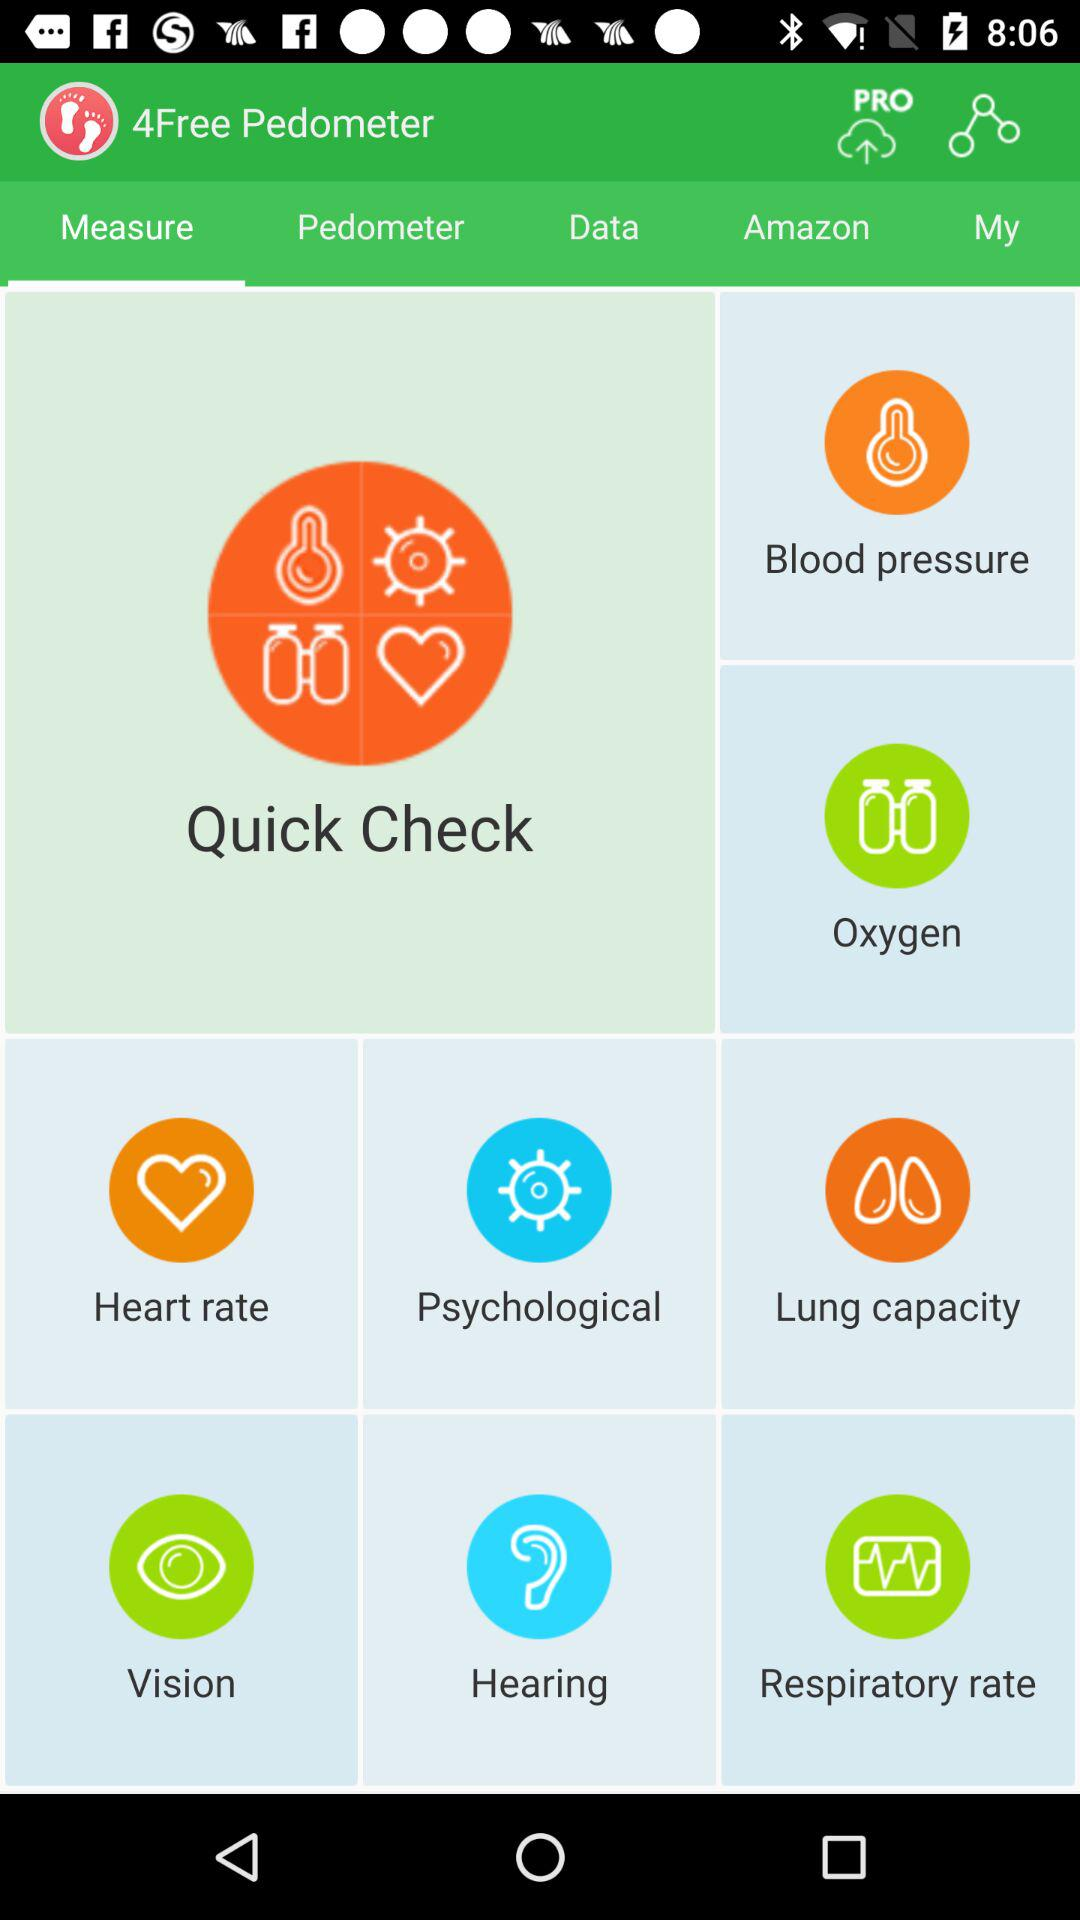What is the name of the application? The name of the application is "4Free Pedometer". 